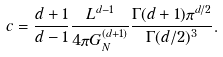<formula> <loc_0><loc_0><loc_500><loc_500>c = \frac { d + 1 } { d - 1 } \frac { L ^ { d - 1 } } { 4 \pi G _ { N } ^ { ( d + 1 ) } } \frac { \Gamma ( d + 1 ) \pi ^ { d / 2 } } { \Gamma ( d / 2 ) ^ { 3 } } .</formula> 